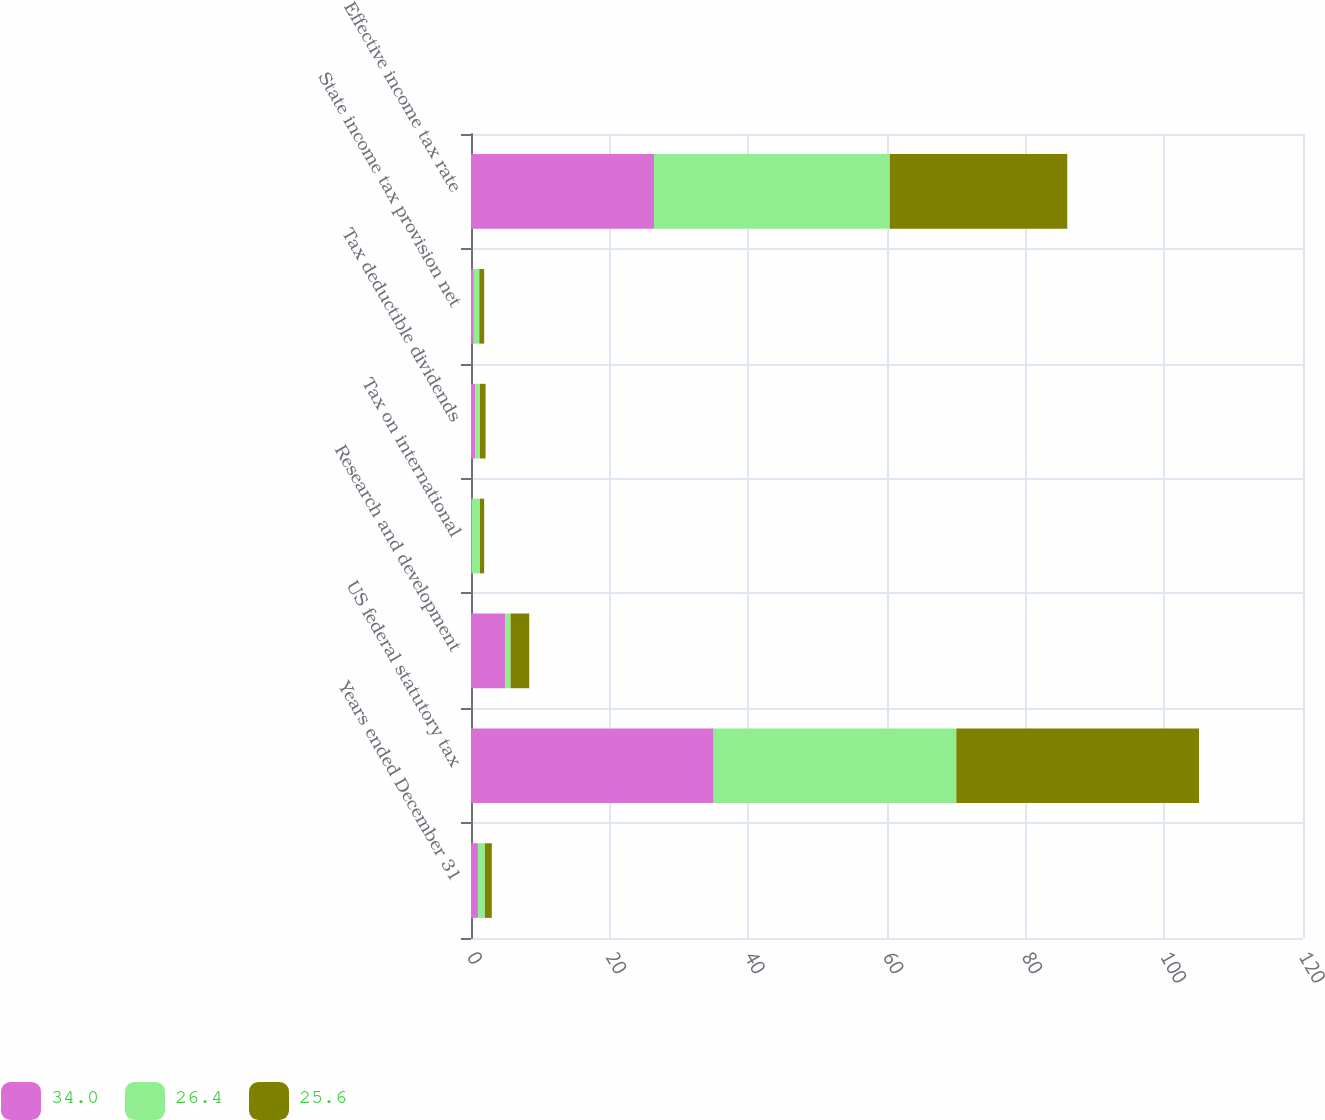Convert chart to OTSL. <chart><loc_0><loc_0><loc_500><loc_500><stacked_bar_chart><ecel><fcel>Years ended December 31<fcel>US federal statutory tax<fcel>Research and development<fcel>Tax on international<fcel>Tax deductible dividends<fcel>State income tax provision net<fcel>Effective income tax rate<nl><fcel>34<fcel>1<fcel>35<fcel>4.9<fcel>0.1<fcel>0.6<fcel>0.4<fcel>26.4<nl><fcel>26.4<fcel>1<fcel>35<fcel>0.8<fcel>1.2<fcel>0.7<fcel>0.8<fcel>34<nl><fcel>25.6<fcel>1<fcel>35<fcel>2.7<fcel>0.6<fcel>0.8<fcel>0.7<fcel>25.6<nl></chart> 